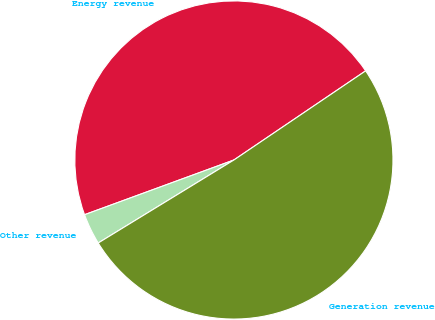<chart> <loc_0><loc_0><loc_500><loc_500><pie_chart><fcel>Energy revenue<fcel>Other revenue<fcel>Generation revenue<nl><fcel>46.12%<fcel>3.15%<fcel>50.73%<nl></chart> 